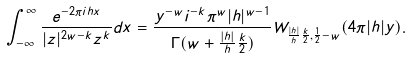<formula> <loc_0><loc_0><loc_500><loc_500>\int _ { - \infty } ^ { \infty } \frac { e ^ { - 2 \pi i h x } } { | z | ^ { 2 w - k } z ^ { k } } d x = \frac { y ^ { - w } i ^ { - k } \pi ^ { w } | h | ^ { w - 1 } } { \Gamma ( w + \frac { | h | } { h } \frac { k } { 2 } ) } W _ { \frac { | h | } { h } \frac { k } { 2 } , \frac { 1 } { 2 } - w } ( 4 \pi | h | y ) .</formula> 